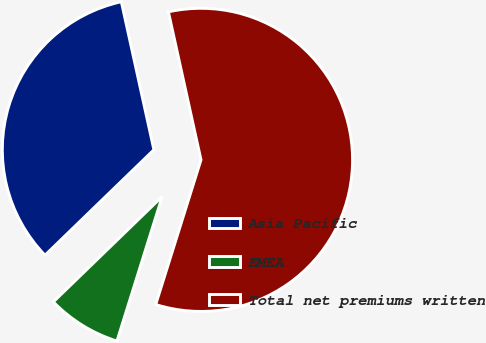Convert chart to OTSL. <chart><loc_0><loc_0><loc_500><loc_500><pie_chart><fcel>Asia Pacific<fcel>EMEA<fcel>Total net premiums written<nl><fcel>33.8%<fcel>7.93%<fcel>58.28%<nl></chart> 